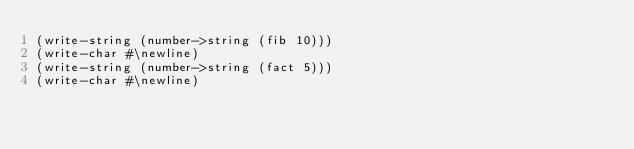<code> <loc_0><loc_0><loc_500><loc_500><_Scheme_>(write-string (number->string (fib 10)))
(write-char #\newline)
(write-string (number->string (fact 5)))
(write-char #\newline)
</code> 